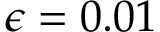<formula> <loc_0><loc_0><loc_500><loc_500>\epsilon = 0 . 0 1</formula> 